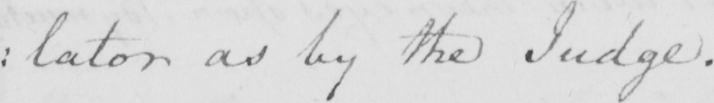Please transcribe the handwritten text in this image. : lator as by the Judge . 